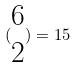<formula> <loc_0><loc_0><loc_500><loc_500>( \begin{matrix} 6 \\ 2 \end{matrix} ) = 1 5</formula> 